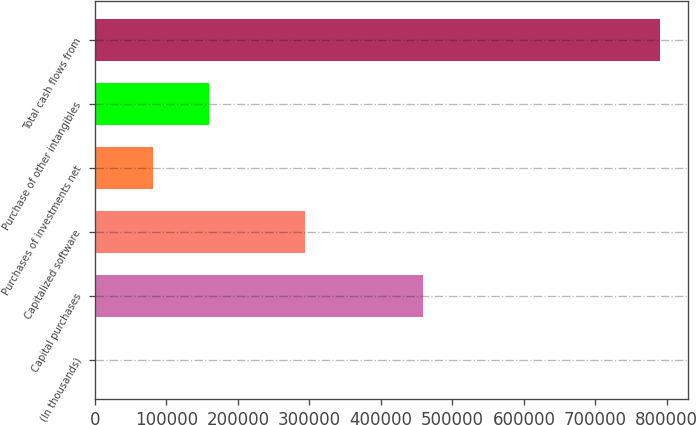<chart> <loc_0><loc_0><loc_500><loc_500><bar_chart><fcel>(In thousands)<fcel>Capital purchases<fcel>Capitalized software<fcel>Purchases of investments net<fcel>Purchase of other intangibles<fcel>Total cash flows from<nl><fcel>2016<fcel>459427<fcel>293696<fcel>80791.8<fcel>159568<fcel>789774<nl></chart> 